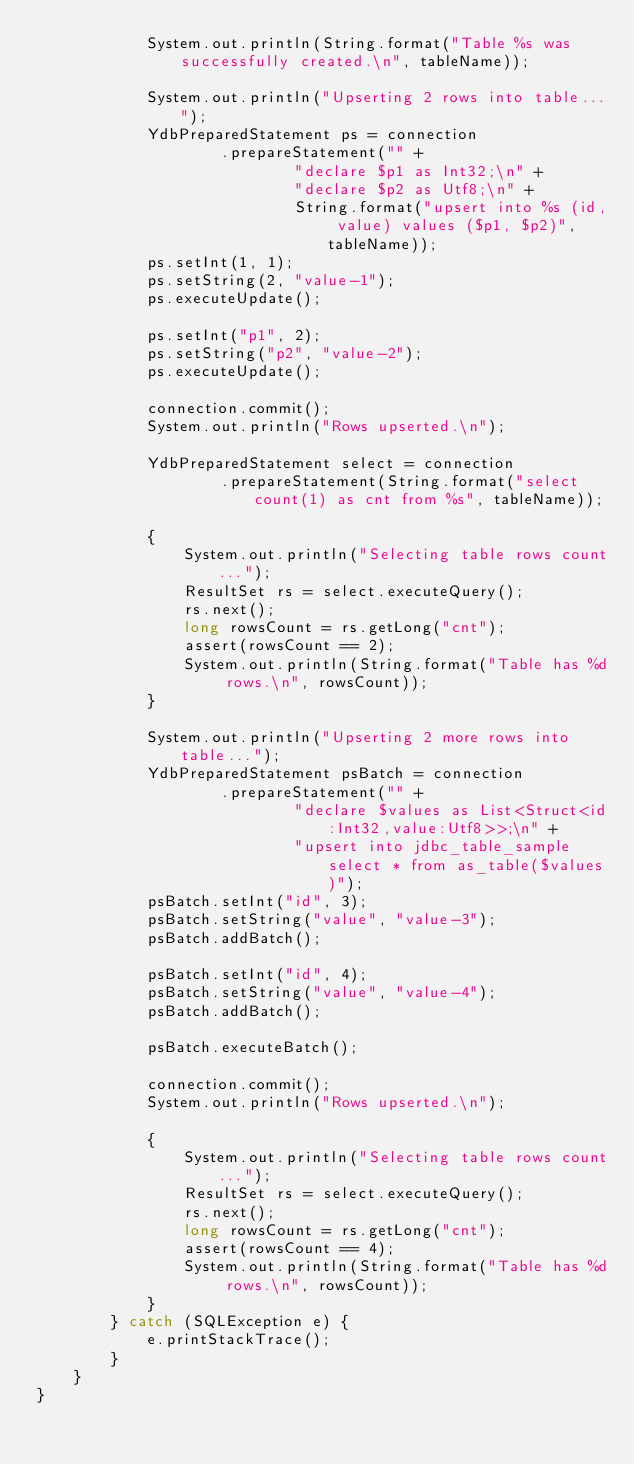Convert code to text. <code><loc_0><loc_0><loc_500><loc_500><_Java_>            System.out.println(String.format("Table %s was successfully created.\n", tableName));

            System.out.println("Upserting 2 rows into table...");
            YdbPreparedStatement ps = connection
                    .prepareStatement("" +
                            "declare $p1 as Int32;\n" +
                            "declare $p2 as Utf8;\n" +
                            String.format("upsert into %s (id, value) values ($p1, $p2)", tableName));
            ps.setInt(1, 1);
            ps.setString(2, "value-1");
            ps.executeUpdate();

            ps.setInt("p1", 2);
            ps.setString("p2", "value-2");
            ps.executeUpdate();

            connection.commit();
            System.out.println("Rows upserted.\n");

            YdbPreparedStatement select = connection
                    .prepareStatement(String.format("select count(1) as cnt from %s", tableName));

            {
                System.out.println("Selecting table rows count...");
                ResultSet rs = select.executeQuery();
                rs.next();
                long rowsCount = rs.getLong("cnt");
                assert(rowsCount == 2);
                System.out.println(String.format("Table has %d rows.\n", rowsCount));
            }

            System.out.println("Upserting 2 more rows into table...");
            YdbPreparedStatement psBatch = connection
                    .prepareStatement("" +
                            "declare $values as List<Struct<id:Int32,value:Utf8>>;\n" +
                            "upsert into jdbc_table_sample select * from as_table($values)");
            psBatch.setInt("id", 3);
            psBatch.setString("value", "value-3");
            psBatch.addBatch();

            psBatch.setInt("id", 4);
            psBatch.setString("value", "value-4");
            psBatch.addBatch();

            psBatch.executeBatch();

            connection.commit();
            System.out.println("Rows upserted.\n");

            {
                System.out.println("Selecting table rows count...");
                ResultSet rs = select.executeQuery();
                rs.next();
                long rowsCount = rs.getLong("cnt");
                assert(rowsCount == 4);
                System.out.println(String.format("Table has %d rows.\n", rowsCount));
            }
        } catch (SQLException e) {
            e.printStackTrace();
        }
    }
}
</code> 